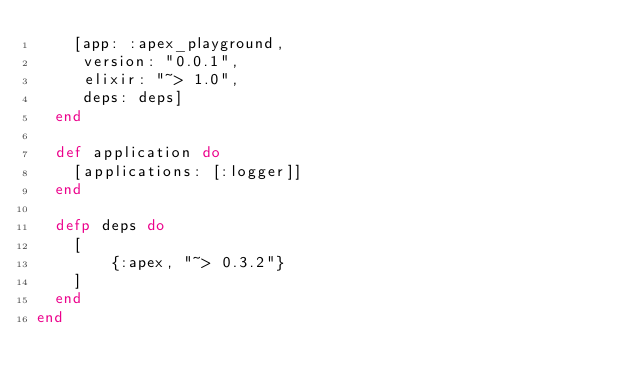Convert code to text. <code><loc_0><loc_0><loc_500><loc_500><_Elixir_>    [app: :apex_playground,
     version: "0.0.1",
     elixir: "~> 1.0",
     deps: deps]
  end

  def application do
    [applications: [:logger]]
  end

  defp deps do
    [
        {:apex, "~> 0.3.2"}
    ]
  end
end
</code> 